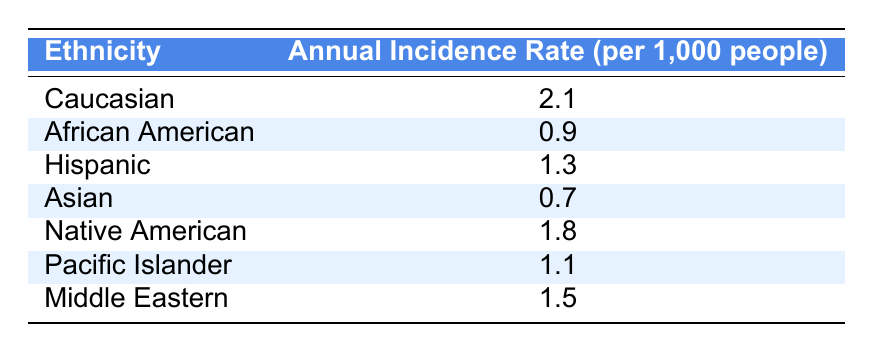What is the annual incidence rate of age-related macular degeneration for Caucasian individuals? The table directly states the incidence rate for Caucasian individuals as 2.1 per 1,000 people.
Answer: 2.1 Which ethnic group has the lowest annual incidence rate of age-related macular degeneration? Referring to the table, Asian individuals have the lowest incidence rate at 0.7 per 1,000 people.
Answer: Asian What is the difference in annual incidence rates between Caucasian and African American individuals? The incidence rate for Caucasian individuals is 2.1 and for African Americans is 0.9. The difference is calculated as 2.1 - 0.9 = 1.2.
Answer: 1.2 What are the annual incidence rates for Hispanic and Native American individuals combined? The incidence rate for Hispanic individuals is 1.3 and for Native Americans is 1.8. Adding these gives 1.3 + 1.8 = 3.1.
Answer: 3.1 What percentage of the population does the annual incidence rate represent for Caucasian individuals compared to the highest rate from the other groups (Native American)? The Caucasian rate is 2.1 and the Native American rate is 1.8. The percentage comparison is (2.1 / 1.8) * 100, which equals about 116.67%.
Answer: 116.67% Which ethnic groups have an incidence rate above 1 per 1,000 people? By checking the values in the table, Caucasian (2.1), Native American (1.8), and Hispanic (1.3) are above 1 per 1,000.
Answer: Caucasian, Native American, Hispanic Is the annual incidence rate for Pacific Islander individuals higher than that for Asian individuals? The table shows that the incidence rate for Pacific Islanders is 1.1, while it is 0.7 for Asians. Thus, 1.1 is higher than 0.7.
Answer: Yes What is the average annual incidence rate across all ethnic groups listed in the table? First sum the annual incidence rates: 2.1 + 0.9 + 1.3 + 0.7 + 1.8 + 1.1 + 1.5 = 9.4. There are 7 ethnic groups, so the average is 9.4 / 7 ≈ 1.34.
Answer: 1.34 Which ethnicity has an annual incidence rate closest to the average calculated above? The average calculated is approximately 1.34. The closest values are Hispanic (1.3) and Middle Eastern (1.5), with Hispanic being slightly lower.
Answer: Hispanic 